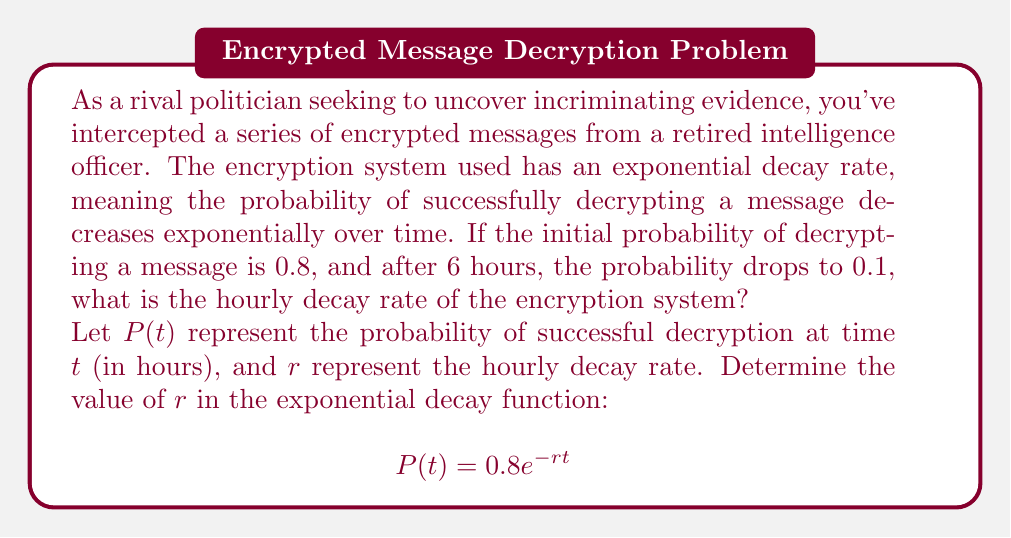Give your solution to this math problem. To solve this problem, we'll use the exponential decay formula and the given information:

1) The general form of exponential decay is:
   $$P(t) = P_0e^{-rt}$$
   where $P_0$ is the initial probability, $r$ is the decay rate, and $t$ is time.

2) We know:
   - Initial probability $P_0 = 0.8$
   - After 6 hours $(t = 6)$, the probability $P(6) = 0.1$

3) Let's substitute these values into the formula:
   $$0.1 = 0.8e^{-r(6)}$$

4) Divide both sides by 0.8:
   $$\frac{0.1}{0.8} = e^{-6r}$$

5) Take the natural logarithm of both sides:
   $$\ln(\frac{0.1}{0.8}) = -6r$$

6) Simplify:
   $$\ln(0.125) = -6r$$

7) Solve for $r$:
   $$r = -\frac{\ln(0.125)}{6}$$

8) Calculate the value:
   $$r = -\frac{-2.0794}{6} \approx 0.3466$$

Therefore, the hourly decay rate is approximately 0.3466 or 34.66% per hour.
Answer: The hourly decay rate of the encryption system is approximately 0.3466 or 34.66% per hour. 